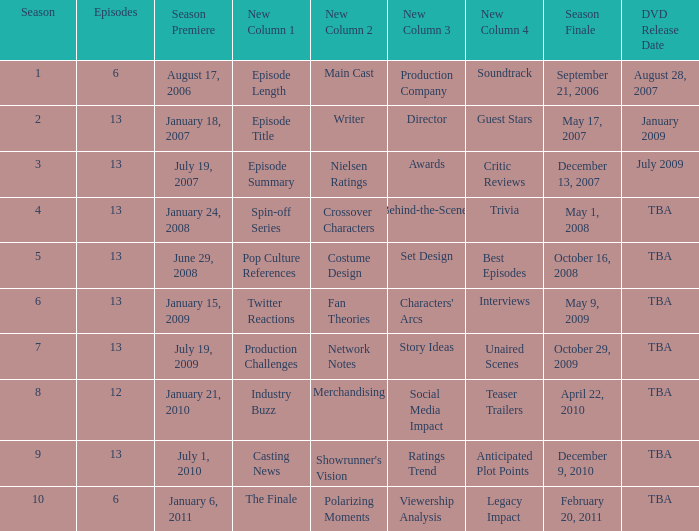On which date was the dvd launched for the season having less than 13 episodes that was broadcasted prior to season 8? August 28, 2007. 